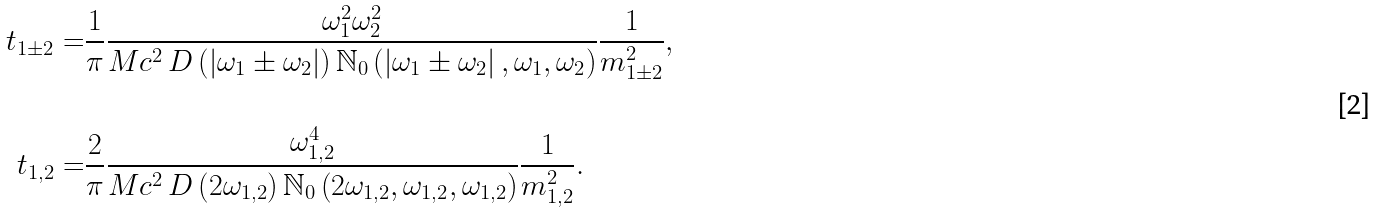<formula> <loc_0><loc_0><loc_500><loc_500>t _ { 1 \pm 2 } = & \frac { 1 } { \pi } \frac { \omega _ { 1 } ^ { 2 } \omega _ { 2 } ^ { 2 } } { M c ^ { 2 } \, D \left ( \left | \omega _ { 1 } \pm \omega _ { 2 } \right | \right ) \mathbb { N } _ { 0 } \left ( \left | \omega _ { 1 } \pm \omega _ { 2 } \right | , \omega _ { 1 } , \omega _ { 2 } \right ) } \frac { 1 } { m _ { 1 \pm 2 } ^ { 2 } } , \\ & \\ t _ { 1 , 2 } = & \frac { 2 } { \pi } \frac { \omega _ { 1 , 2 } ^ { 4 } } { M c ^ { 2 } \, D \left ( 2 \omega _ { 1 , 2 } \right ) \mathbb { N } _ { 0 } \left ( 2 \omega _ { 1 , 2 } , \omega _ { 1 , 2 } , \omega _ { 1 , 2 } \right ) } \frac { 1 } { m _ { 1 , 2 } ^ { 2 } } .</formula> 